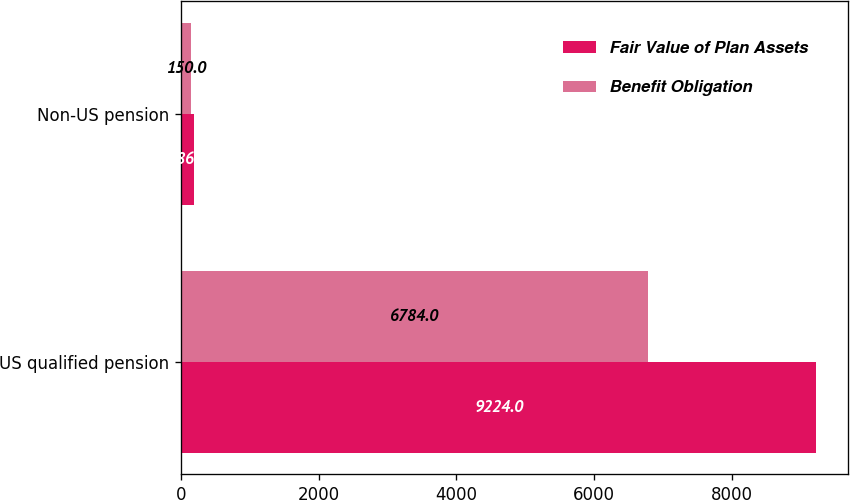<chart> <loc_0><loc_0><loc_500><loc_500><stacked_bar_chart><ecel><fcel>US qualified pension<fcel>Non-US pension<nl><fcel>Fair Value of Plan Assets<fcel>9224<fcel>186<nl><fcel>Benefit Obligation<fcel>6784<fcel>150<nl></chart> 